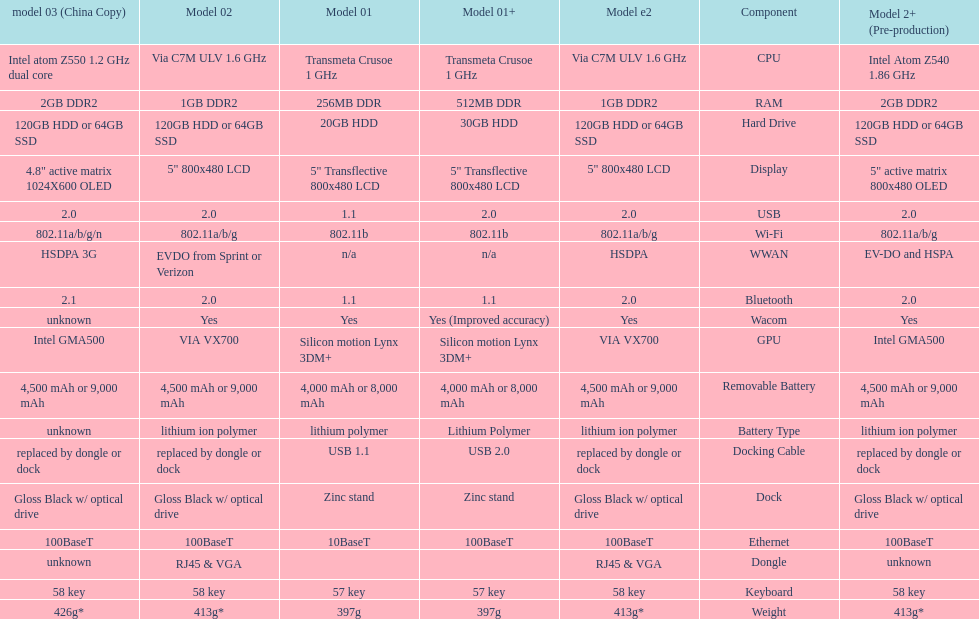What component comes after bluetooth? Wacom. 